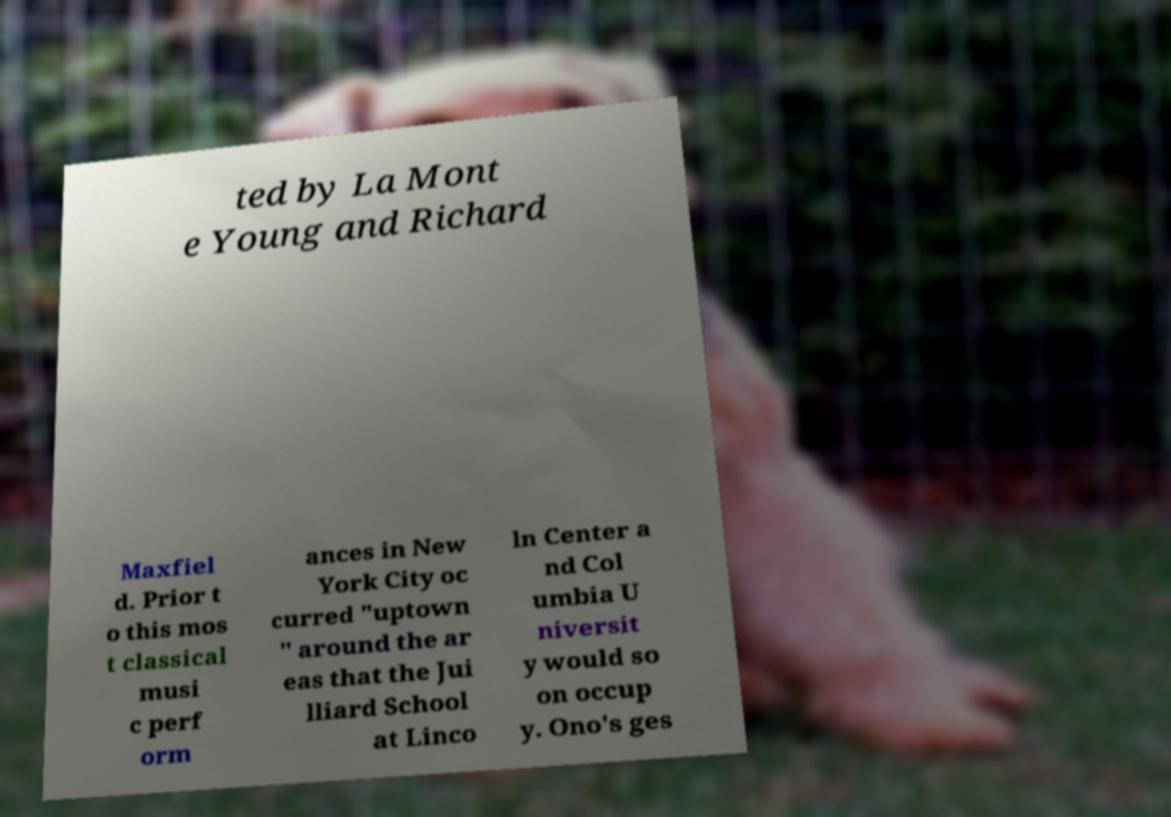What messages or text are displayed in this image? I need them in a readable, typed format. ted by La Mont e Young and Richard Maxfiel d. Prior t o this mos t classical musi c perf orm ances in New York City oc curred "uptown " around the ar eas that the Jui lliard School at Linco ln Center a nd Col umbia U niversit y would so on occup y. Ono's ges 